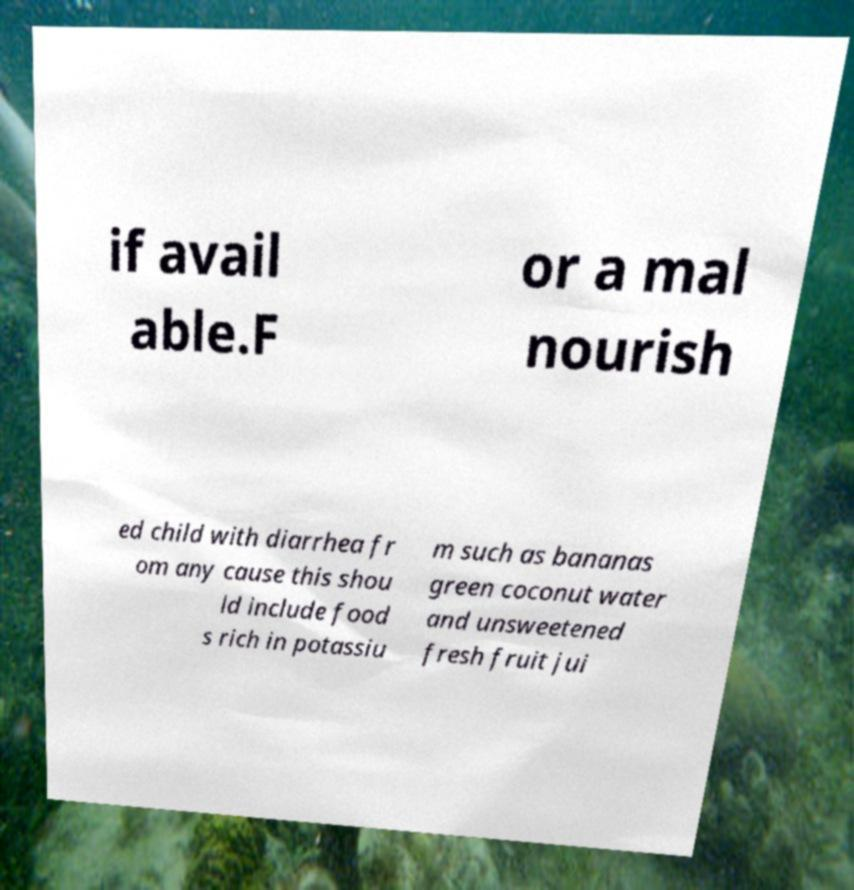Can you read and provide the text displayed in the image?This photo seems to have some interesting text. Can you extract and type it out for me? if avail able.F or a mal nourish ed child with diarrhea fr om any cause this shou ld include food s rich in potassiu m such as bananas green coconut water and unsweetened fresh fruit jui 